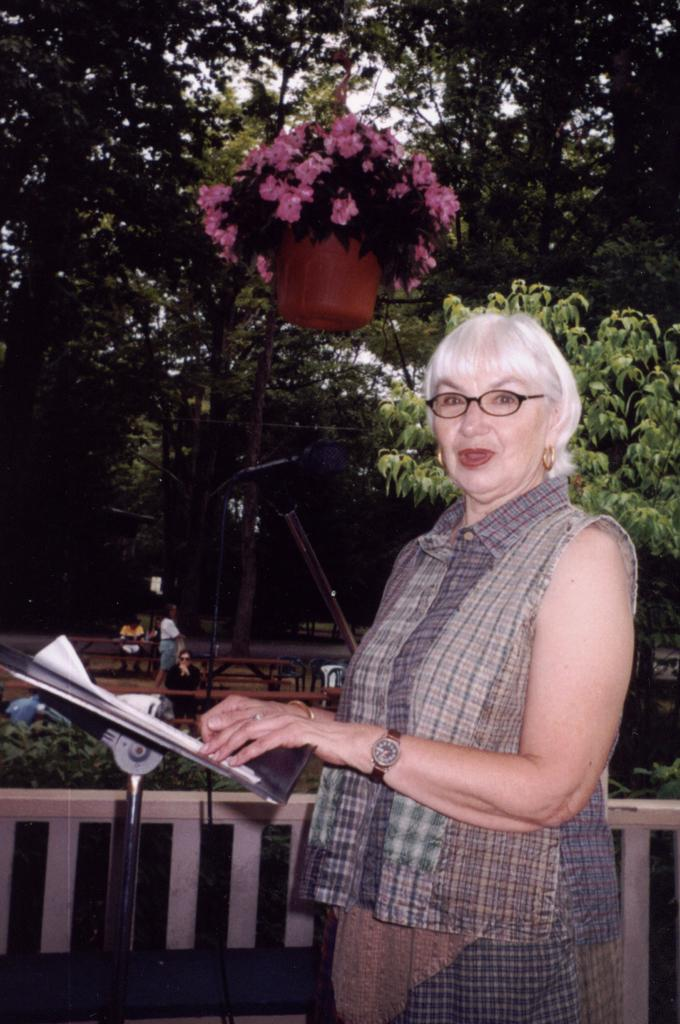Who is the main subject in the image? There is a woman in the image. What is the woman doing in the image? The woman is standing in front of a table. What can be seen in the background of the image? There are many trees behind the woman. Are there any other people visible in the image? Yes, there are people present among the trees. What type of fan is the woman using to cool herself in the image? There is no fan present in the image; the woman is standing in front of a table. What book is the woman reading in the image? There is no book or reading activity depicted in the image. 